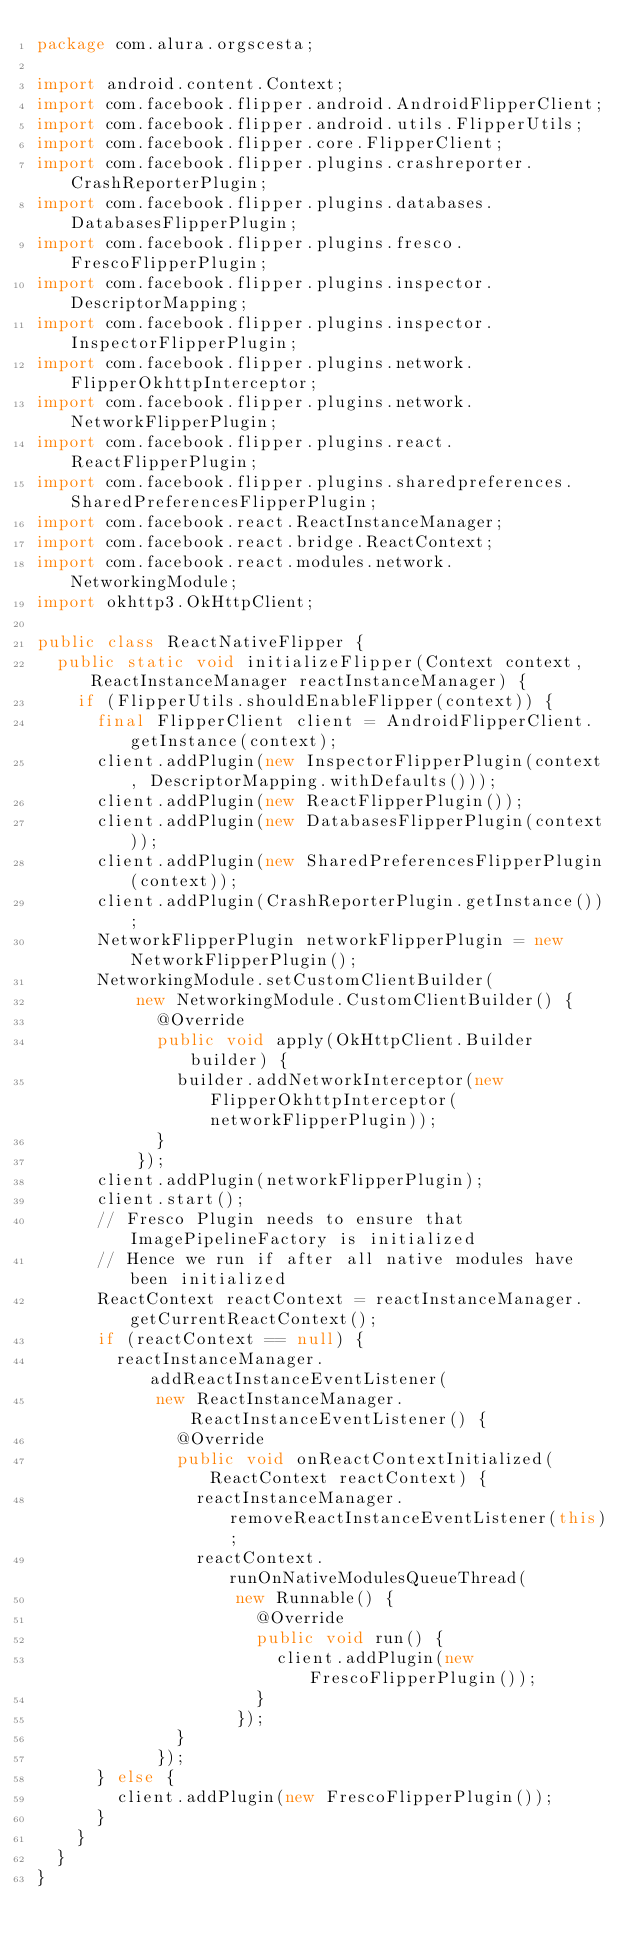<code> <loc_0><loc_0><loc_500><loc_500><_Java_>package com.alura.orgscesta;

import android.content.Context;
import com.facebook.flipper.android.AndroidFlipperClient;
import com.facebook.flipper.android.utils.FlipperUtils;
import com.facebook.flipper.core.FlipperClient;
import com.facebook.flipper.plugins.crashreporter.CrashReporterPlugin;
import com.facebook.flipper.plugins.databases.DatabasesFlipperPlugin;
import com.facebook.flipper.plugins.fresco.FrescoFlipperPlugin;
import com.facebook.flipper.plugins.inspector.DescriptorMapping;
import com.facebook.flipper.plugins.inspector.InspectorFlipperPlugin;
import com.facebook.flipper.plugins.network.FlipperOkhttpInterceptor;
import com.facebook.flipper.plugins.network.NetworkFlipperPlugin;
import com.facebook.flipper.plugins.react.ReactFlipperPlugin;
import com.facebook.flipper.plugins.sharedpreferences.SharedPreferencesFlipperPlugin;
import com.facebook.react.ReactInstanceManager;
import com.facebook.react.bridge.ReactContext;
import com.facebook.react.modules.network.NetworkingModule;
import okhttp3.OkHttpClient;

public class ReactNativeFlipper {
  public static void initializeFlipper(Context context, ReactInstanceManager reactInstanceManager) {
    if (FlipperUtils.shouldEnableFlipper(context)) {
      final FlipperClient client = AndroidFlipperClient.getInstance(context);
      client.addPlugin(new InspectorFlipperPlugin(context, DescriptorMapping.withDefaults()));
      client.addPlugin(new ReactFlipperPlugin());
      client.addPlugin(new DatabasesFlipperPlugin(context));
      client.addPlugin(new SharedPreferencesFlipperPlugin(context));
      client.addPlugin(CrashReporterPlugin.getInstance());
      NetworkFlipperPlugin networkFlipperPlugin = new NetworkFlipperPlugin();
      NetworkingModule.setCustomClientBuilder(
          new NetworkingModule.CustomClientBuilder() {
            @Override
            public void apply(OkHttpClient.Builder builder) {
              builder.addNetworkInterceptor(new FlipperOkhttpInterceptor(networkFlipperPlugin));
            }
          });
      client.addPlugin(networkFlipperPlugin);
      client.start();
      // Fresco Plugin needs to ensure that ImagePipelineFactory is initialized
      // Hence we run if after all native modules have been initialized
      ReactContext reactContext = reactInstanceManager.getCurrentReactContext();
      if (reactContext == null) {
        reactInstanceManager.addReactInstanceEventListener(
            new ReactInstanceManager.ReactInstanceEventListener() {
              @Override
              public void onReactContextInitialized(ReactContext reactContext) {
                reactInstanceManager.removeReactInstanceEventListener(this);
                reactContext.runOnNativeModulesQueueThread(
                    new Runnable() {
                      @Override
                      public void run() {
                        client.addPlugin(new FrescoFlipperPlugin());
                      }
                    });
              }
            });
      } else {
        client.addPlugin(new FrescoFlipperPlugin());
      }
    }
  }
}</code> 